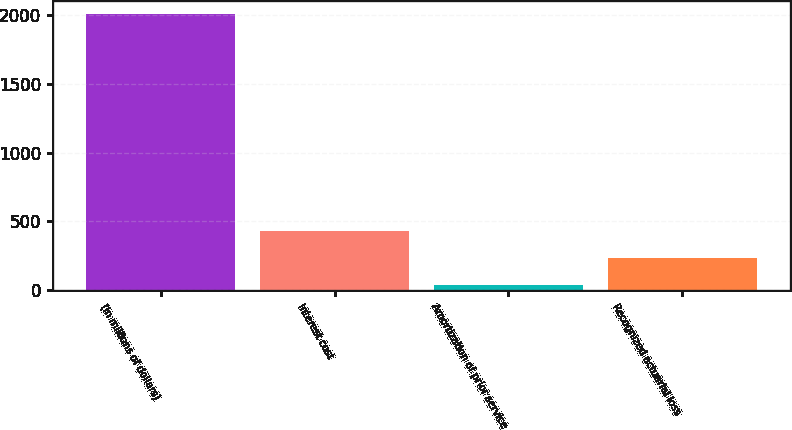<chart> <loc_0><loc_0><loc_500><loc_500><bar_chart><fcel>(In millions of dollars)<fcel>Interest cost<fcel>Amortization of prior service<fcel>Recognized actuarial loss<nl><fcel>2004<fcel>431.2<fcel>38<fcel>234.6<nl></chart> 